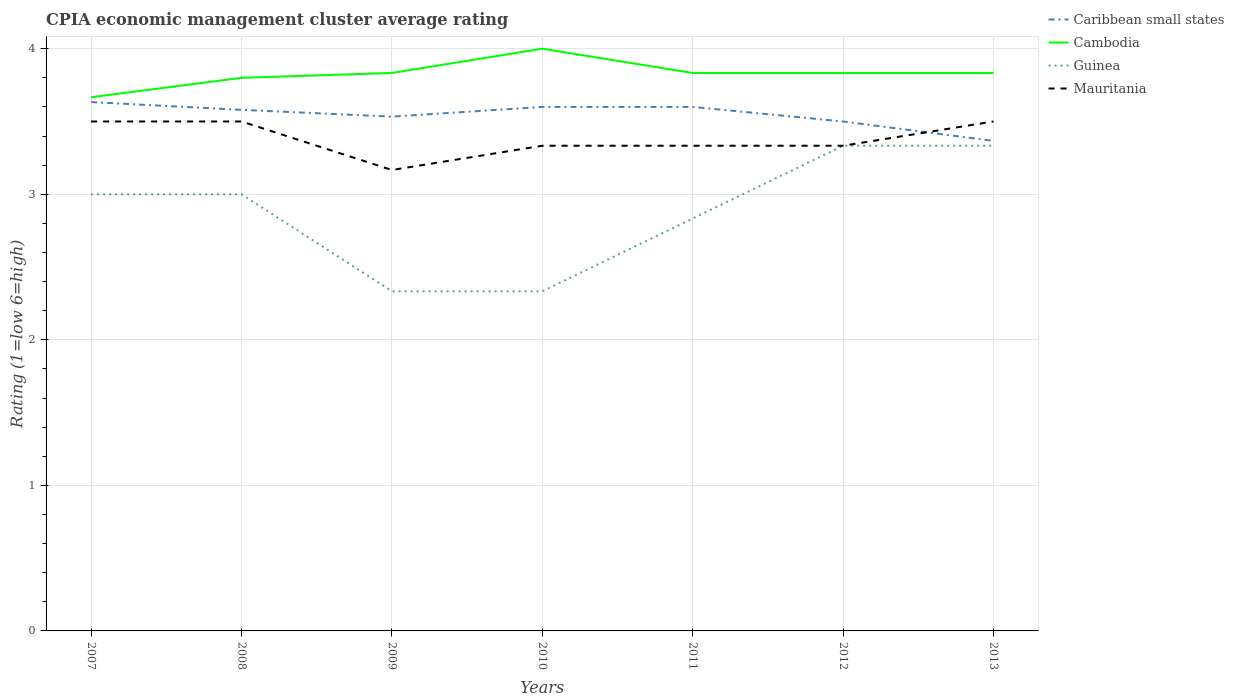How many different coloured lines are there?
Make the answer very short. 4. Does the line corresponding to Cambodia intersect with the line corresponding to Guinea?
Make the answer very short. No. Is the number of lines equal to the number of legend labels?
Give a very brief answer. Yes. Across all years, what is the maximum CPIA rating in Caribbean small states?
Your answer should be compact. 3.37. In which year was the CPIA rating in Cambodia maximum?
Keep it short and to the point. 2007. What is the total CPIA rating in Cambodia in the graph?
Provide a succinct answer. -0.17. What is the difference between the highest and the second highest CPIA rating in Caribbean small states?
Offer a terse response. 0.27. What is the difference between the highest and the lowest CPIA rating in Mauritania?
Give a very brief answer. 3. Is the CPIA rating in Mauritania strictly greater than the CPIA rating in Cambodia over the years?
Provide a succinct answer. Yes. How many lines are there?
Your answer should be compact. 4. How many years are there in the graph?
Your response must be concise. 7. Are the values on the major ticks of Y-axis written in scientific E-notation?
Give a very brief answer. No. Does the graph contain any zero values?
Give a very brief answer. No. Does the graph contain grids?
Your answer should be very brief. Yes. Where does the legend appear in the graph?
Keep it short and to the point. Top right. How are the legend labels stacked?
Keep it short and to the point. Vertical. What is the title of the graph?
Make the answer very short. CPIA economic management cluster average rating. Does "Euro area" appear as one of the legend labels in the graph?
Your answer should be very brief. No. What is the Rating (1=low 6=high) in Caribbean small states in 2007?
Your answer should be compact. 3.63. What is the Rating (1=low 6=high) of Cambodia in 2007?
Your answer should be compact. 3.67. What is the Rating (1=low 6=high) of Mauritania in 2007?
Keep it short and to the point. 3.5. What is the Rating (1=low 6=high) of Caribbean small states in 2008?
Give a very brief answer. 3.58. What is the Rating (1=low 6=high) of Cambodia in 2008?
Your answer should be very brief. 3.8. What is the Rating (1=low 6=high) in Mauritania in 2008?
Keep it short and to the point. 3.5. What is the Rating (1=low 6=high) in Caribbean small states in 2009?
Give a very brief answer. 3.53. What is the Rating (1=low 6=high) of Cambodia in 2009?
Keep it short and to the point. 3.83. What is the Rating (1=low 6=high) of Guinea in 2009?
Make the answer very short. 2.33. What is the Rating (1=low 6=high) in Mauritania in 2009?
Offer a very short reply. 3.17. What is the Rating (1=low 6=high) in Caribbean small states in 2010?
Provide a succinct answer. 3.6. What is the Rating (1=low 6=high) in Cambodia in 2010?
Keep it short and to the point. 4. What is the Rating (1=low 6=high) in Guinea in 2010?
Your answer should be compact. 2.33. What is the Rating (1=low 6=high) of Mauritania in 2010?
Provide a succinct answer. 3.33. What is the Rating (1=low 6=high) in Caribbean small states in 2011?
Make the answer very short. 3.6. What is the Rating (1=low 6=high) in Cambodia in 2011?
Give a very brief answer. 3.83. What is the Rating (1=low 6=high) of Guinea in 2011?
Keep it short and to the point. 2.83. What is the Rating (1=low 6=high) of Mauritania in 2011?
Keep it short and to the point. 3.33. What is the Rating (1=low 6=high) of Cambodia in 2012?
Provide a short and direct response. 3.83. What is the Rating (1=low 6=high) in Guinea in 2012?
Offer a terse response. 3.33. What is the Rating (1=low 6=high) of Mauritania in 2012?
Your answer should be very brief. 3.33. What is the Rating (1=low 6=high) in Caribbean small states in 2013?
Your answer should be very brief. 3.37. What is the Rating (1=low 6=high) of Cambodia in 2013?
Offer a very short reply. 3.83. What is the Rating (1=low 6=high) in Guinea in 2013?
Offer a terse response. 3.33. Across all years, what is the maximum Rating (1=low 6=high) of Caribbean small states?
Offer a terse response. 3.63. Across all years, what is the maximum Rating (1=low 6=high) of Cambodia?
Your response must be concise. 4. Across all years, what is the maximum Rating (1=low 6=high) of Guinea?
Ensure brevity in your answer.  3.33. Across all years, what is the maximum Rating (1=low 6=high) of Mauritania?
Your response must be concise. 3.5. Across all years, what is the minimum Rating (1=low 6=high) in Caribbean small states?
Provide a succinct answer. 3.37. Across all years, what is the minimum Rating (1=low 6=high) of Cambodia?
Keep it short and to the point. 3.67. Across all years, what is the minimum Rating (1=low 6=high) in Guinea?
Offer a terse response. 2.33. Across all years, what is the minimum Rating (1=low 6=high) of Mauritania?
Your answer should be compact. 3.17. What is the total Rating (1=low 6=high) of Caribbean small states in the graph?
Keep it short and to the point. 24.81. What is the total Rating (1=low 6=high) of Cambodia in the graph?
Ensure brevity in your answer.  26.8. What is the total Rating (1=low 6=high) of Guinea in the graph?
Your answer should be very brief. 20.17. What is the total Rating (1=low 6=high) in Mauritania in the graph?
Your answer should be compact. 23.67. What is the difference between the Rating (1=low 6=high) of Caribbean small states in 2007 and that in 2008?
Offer a terse response. 0.05. What is the difference between the Rating (1=low 6=high) of Cambodia in 2007 and that in 2008?
Your response must be concise. -0.13. What is the difference between the Rating (1=low 6=high) in Caribbean small states in 2007 and that in 2009?
Ensure brevity in your answer.  0.1. What is the difference between the Rating (1=low 6=high) in Caribbean small states in 2007 and that in 2010?
Keep it short and to the point. 0.03. What is the difference between the Rating (1=low 6=high) in Guinea in 2007 and that in 2010?
Give a very brief answer. 0.67. What is the difference between the Rating (1=low 6=high) of Mauritania in 2007 and that in 2010?
Offer a terse response. 0.17. What is the difference between the Rating (1=low 6=high) of Caribbean small states in 2007 and that in 2011?
Provide a succinct answer. 0.03. What is the difference between the Rating (1=low 6=high) in Caribbean small states in 2007 and that in 2012?
Your answer should be very brief. 0.13. What is the difference between the Rating (1=low 6=high) of Cambodia in 2007 and that in 2012?
Provide a short and direct response. -0.17. What is the difference between the Rating (1=low 6=high) of Caribbean small states in 2007 and that in 2013?
Provide a short and direct response. 0.27. What is the difference between the Rating (1=low 6=high) in Cambodia in 2007 and that in 2013?
Offer a terse response. -0.17. What is the difference between the Rating (1=low 6=high) of Mauritania in 2007 and that in 2013?
Offer a very short reply. 0. What is the difference between the Rating (1=low 6=high) in Caribbean small states in 2008 and that in 2009?
Your response must be concise. 0.05. What is the difference between the Rating (1=low 6=high) in Cambodia in 2008 and that in 2009?
Give a very brief answer. -0.03. What is the difference between the Rating (1=low 6=high) in Caribbean small states in 2008 and that in 2010?
Your response must be concise. -0.02. What is the difference between the Rating (1=low 6=high) of Caribbean small states in 2008 and that in 2011?
Ensure brevity in your answer.  -0.02. What is the difference between the Rating (1=low 6=high) of Cambodia in 2008 and that in 2011?
Your response must be concise. -0.03. What is the difference between the Rating (1=low 6=high) in Cambodia in 2008 and that in 2012?
Provide a succinct answer. -0.03. What is the difference between the Rating (1=low 6=high) in Caribbean small states in 2008 and that in 2013?
Ensure brevity in your answer.  0.21. What is the difference between the Rating (1=low 6=high) in Cambodia in 2008 and that in 2013?
Offer a very short reply. -0.03. What is the difference between the Rating (1=low 6=high) of Caribbean small states in 2009 and that in 2010?
Give a very brief answer. -0.07. What is the difference between the Rating (1=low 6=high) of Caribbean small states in 2009 and that in 2011?
Make the answer very short. -0.07. What is the difference between the Rating (1=low 6=high) of Mauritania in 2009 and that in 2011?
Ensure brevity in your answer.  -0.17. What is the difference between the Rating (1=low 6=high) in Guinea in 2009 and that in 2012?
Your response must be concise. -1. What is the difference between the Rating (1=low 6=high) of Mauritania in 2009 and that in 2012?
Your response must be concise. -0.17. What is the difference between the Rating (1=low 6=high) of Caribbean small states in 2010 and that in 2011?
Offer a terse response. 0. What is the difference between the Rating (1=low 6=high) in Cambodia in 2010 and that in 2011?
Give a very brief answer. 0.17. What is the difference between the Rating (1=low 6=high) in Mauritania in 2010 and that in 2011?
Provide a short and direct response. 0. What is the difference between the Rating (1=low 6=high) in Cambodia in 2010 and that in 2012?
Offer a very short reply. 0.17. What is the difference between the Rating (1=low 6=high) of Guinea in 2010 and that in 2012?
Offer a terse response. -1. What is the difference between the Rating (1=low 6=high) of Mauritania in 2010 and that in 2012?
Provide a short and direct response. 0. What is the difference between the Rating (1=low 6=high) in Caribbean small states in 2010 and that in 2013?
Provide a succinct answer. 0.23. What is the difference between the Rating (1=low 6=high) of Mauritania in 2010 and that in 2013?
Your answer should be compact. -0.17. What is the difference between the Rating (1=low 6=high) of Caribbean small states in 2011 and that in 2012?
Your response must be concise. 0.1. What is the difference between the Rating (1=low 6=high) of Guinea in 2011 and that in 2012?
Keep it short and to the point. -0.5. What is the difference between the Rating (1=low 6=high) of Mauritania in 2011 and that in 2012?
Your answer should be very brief. 0. What is the difference between the Rating (1=low 6=high) in Caribbean small states in 2011 and that in 2013?
Provide a short and direct response. 0.23. What is the difference between the Rating (1=low 6=high) in Cambodia in 2011 and that in 2013?
Your answer should be very brief. 0. What is the difference between the Rating (1=low 6=high) of Guinea in 2011 and that in 2013?
Your answer should be very brief. -0.5. What is the difference between the Rating (1=low 6=high) in Mauritania in 2011 and that in 2013?
Offer a terse response. -0.17. What is the difference between the Rating (1=low 6=high) in Caribbean small states in 2012 and that in 2013?
Keep it short and to the point. 0.13. What is the difference between the Rating (1=low 6=high) of Cambodia in 2012 and that in 2013?
Offer a terse response. 0. What is the difference between the Rating (1=low 6=high) in Caribbean small states in 2007 and the Rating (1=low 6=high) in Cambodia in 2008?
Offer a very short reply. -0.17. What is the difference between the Rating (1=low 6=high) of Caribbean small states in 2007 and the Rating (1=low 6=high) of Guinea in 2008?
Your answer should be compact. 0.63. What is the difference between the Rating (1=low 6=high) in Caribbean small states in 2007 and the Rating (1=low 6=high) in Mauritania in 2008?
Offer a terse response. 0.13. What is the difference between the Rating (1=low 6=high) in Guinea in 2007 and the Rating (1=low 6=high) in Mauritania in 2008?
Your answer should be very brief. -0.5. What is the difference between the Rating (1=low 6=high) of Caribbean small states in 2007 and the Rating (1=low 6=high) of Cambodia in 2009?
Keep it short and to the point. -0.2. What is the difference between the Rating (1=low 6=high) in Caribbean small states in 2007 and the Rating (1=low 6=high) in Mauritania in 2009?
Your response must be concise. 0.47. What is the difference between the Rating (1=low 6=high) in Cambodia in 2007 and the Rating (1=low 6=high) in Mauritania in 2009?
Give a very brief answer. 0.5. What is the difference between the Rating (1=low 6=high) of Caribbean small states in 2007 and the Rating (1=low 6=high) of Cambodia in 2010?
Your response must be concise. -0.37. What is the difference between the Rating (1=low 6=high) of Caribbean small states in 2007 and the Rating (1=low 6=high) of Mauritania in 2010?
Your answer should be compact. 0.3. What is the difference between the Rating (1=low 6=high) of Caribbean small states in 2007 and the Rating (1=low 6=high) of Cambodia in 2011?
Your response must be concise. -0.2. What is the difference between the Rating (1=low 6=high) of Caribbean small states in 2007 and the Rating (1=low 6=high) of Guinea in 2011?
Provide a short and direct response. 0.8. What is the difference between the Rating (1=low 6=high) of Cambodia in 2007 and the Rating (1=low 6=high) of Guinea in 2011?
Provide a short and direct response. 0.83. What is the difference between the Rating (1=low 6=high) of Cambodia in 2007 and the Rating (1=low 6=high) of Mauritania in 2011?
Your response must be concise. 0.33. What is the difference between the Rating (1=low 6=high) in Caribbean small states in 2007 and the Rating (1=low 6=high) in Cambodia in 2012?
Your answer should be very brief. -0.2. What is the difference between the Rating (1=low 6=high) in Caribbean small states in 2007 and the Rating (1=low 6=high) in Guinea in 2012?
Your answer should be very brief. 0.3. What is the difference between the Rating (1=low 6=high) in Cambodia in 2007 and the Rating (1=low 6=high) in Guinea in 2012?
Offer a terse response. 0.33. What is the difference between the Rating (1=low 6=high) in Guinea in 2007 and the Rating (1=low 6=high) in Mauritania in 2012?
Your answer should be very brief. -0.33. What is the difference between the Rating (1=low 6=high) in Caribbean small states in 2007 and the Rating (1=low 6=high) in Cambodia in 2013?
Give a very brief answer. -0.2. What is the difference between the Rating (1=low 6=high) of Caribbean small states in 2007 and the Rating (1=low 6=high) of Guinea in 2013?
Your answer should be very brief. 0.3. What is the difference between the Rating (1=low 6=high) in Caribbean small states in 2007 and the Rating (1=low 6=high) in Mauritania in 2013?
Your answer should be very brief. 0.13. What is the difference between the Rating (1=low 6=high) of Caribbean small states in 2008 and the Rating (1=low 6=high) of Cambodia in 2009?
Offer a very short reply. -0.25. What is the difference between the Rating (1=low 6=high) in Caribbean small states in 2008 and the Rating (1=low 6=high) in Guinea in 2009?
Give a very brief answer. 1.25. What is the difference between the Rating (1=low 6=high) in Caribbean small states in 2008 and the Rating (1=low 6=high) in Mauritania in 2009?
Your answer should be compact. 0.41. What is the difference between the Rating (1=low 6=high) in Cambodia in 2008 and the Rating (1=low 6=high) in Guinea in 2009?
Your answer should be compact. 1.47. What is the difference between the Rating (1=low 6=high) of Cambodia in 2008 and the Rating (1=low 6=high) of Mauritania in 2009?
Provide a succinct answer. 0.63. What is the difference between the Rating (1=low 6=high) of Caribbean small states in 2008 and the Rating (1=low 6=high) of Cambodia in 2010?
Offer a terse response. -0.42. What is the difference between the Rating (1=low 6=high) of Caribbean small states in 2008 and the Rating (1=low 6=high) of Guinea in 2010?
Offer a very short reply. 1.25. What is the difference between the Rating (1=low 6=high) of Caribbean small states in 2008 and the Rating (1=low 6=high) of Mauritania in 2010?
Your answer should be very brief. 0.25. What is the difference between the Rating (1=low 6=high) in Cambodia in 2008 and the Rating (1=low 6=high) in Guinea in 2010?
Provide a succinct answer. 1.47. What is the difference between the Rating (1=low 6=high) of Cambodia in 2008 and the Rating (1=low 6=high) of Mauritania in 2010?
Make the answer very short. 0.47. What is the difference between the Rating (1=low 6=high) of Caribbean small states in 2008 and the Rating (1=low 6=high) of Cambodia in 2011?
Provide a succinct answer. -0.25. What is the difference between the Rating (1=low 6=high) of Caribbean small states in 2008 and the Rating (1=low 6=high) of Guinea in 2011?
Offer a very short reply. 0.75. What is the difference between the Rating (1=low 6=high) in Caribbean small states in 2008 and the Rating (1=low 6=high) in Mauritania in 2011?
Ensure brevity in your answer.  0.25. What is the difference between the Rating (1=low 6=high) of Cambodia in 2008 and the Rating (1=low 6=high) of Guinea in 2011?
Make the answer very short. 0.97. What is the difference between the Rating (1=low 6=high) of Cambodia in 2008 and the Rating (1=low 6=high) of Mauritania in 2011?
Offer a terse response. 0.47. What is the difference between the Rating (1=low 6=high) of Caribbean small states in 2008 and the Rating (1=low 6=high) of Cambodia in 2012?
Provide a short and direct response. -0.25. What is the difference between the Rating (1=low 6=high) in Caribbean small states in 2008 and the Rating (1=low 6=high) in Guinea in 2012?
Give a very brief answer. 0.25. What is the difference between the Rating (1=low 6=high) of Caribbean small states in 2008 and the Rating (1=low 6=high) of Mauritania in 2012?
Provide a succinct answer. 0.25. What is the difference between the Rating (1=low 6=high) of Cambodia in 2008 and the Rating (1=low 6=high) of Guinea in 2012?
Your answer should be very brief. 0.47. What is the difference between the Rating (1=low 6=high) in Cambodia in 2008 and the Rating (1=low 6=high) in Mauritania in 2012?
Keep it short and to the point. 0.47. What is the difference between the Rating (1=low 6=high) in Guinea in 2008 and the Rating (1=low 6=high) in Mauritania in 2012?
Your response must be concise. -0.33. What is the difference between the Rating (1=low 6=high) in Caribbean small states in 2008 and the Rating (1=low 6=high) in Cambodia in 2013?
Provide a succinct answer. -0.25. What is the difference between the Rating (1=low 6=high) of Caribbean small states in 2008 and the Rating (1=low 6=high) of Guinea in 2013?
Offer a very short reply. 0.25. What is the difference between the Rating (1=low 6=high) of Cambodia in 2008 and the Rating (1=low 6=high) of Guinea in 2013?
Provide a short and direct response. 0.47. What is the difference between the Rating (1=low 6=high) in Guinea in 2008 and the Rating (1=low 6=high) in Mauritania in 2013?
Your answer should be compact. -0.5. What is the difference between the Rating (1=low 6=high) of Caribbean small states in 2009 and the Rating (1=low 6=high) of Cambodia in 2010?
Ensure brevity in your answer.  -0.47. What is the difference between the Rating (1=low 6=high) in Caribbean small states in 2009 and the Rating (1=low 6=high) in Guinea in 2010?
Ensure brevity in your answer.  1.2. What is the difference between the Rating (1=low 6=high) in Caribbean small states in 2009 and the Rating (1=low 6=high) in Mauritania in 2010?
Provide a short and direct response. 0.2. What is the difference between the Rating (1=low 6=high) of Cambodia in 2009 and the Rating (1=low 6=high) of Mauritania in 2010?
Your answer should be compact. 0.5. What is the difference between the Rating (1=low 6=high) in Guinea in 2009 and the Rating (1=low 6=high) in Mauritania in 2010?
Make the answer very short. -1. What is the difference between the Rating (1=low 6=high) of Caribbean small states in 2009 and the Rating (1=low 6=high) of Cambodia in 2011?
Give a very brief answer. -0.3. What is the difference between the Rating (1=low 6=high) of Caribbean small states in 2009 and the Rating (1=low 6=high) of Guinea in 2011?
Your response must be concise. 0.7. What is the difference between the Rating (1=low 6=high) of Caribbean small states in 2009 and the Rating (1=low 6=high) of Mauritania in 2011?
Keep it short and to the point. 0.2. What is the difference between the Rating (1=low 6=high) in Cambodia in 2009 and the Rating (1=low 6=high) in Mauritania in 2011?
Give a very brief answer. 0.5. What is the difference between the Rating (1=low 6=high) of Guinea in 2009 and the Rating (1=low 6=high) of Mauritania in 2011?
Provide a short and direct response. -1. What is the difference between the Rating (1=low 6=high) of Caribbean small states in 2009 and the Rating (1=low 6=high) of Mauritania in 2012?
Your answer should be very brief. 0.2. What is the difference between the Rating (1=low 6=high) in Cambodia in 2009 and the Rating (1=low 6=high) in Guinea in 2012?
Your response must be concise. 0.5. What is the difference between the Rating (1=low 6=high) of Cambodia in 2009 and the Rating (1=low 6=high) of Mauritania in 2012?
Provide a short and direct response. 0.5. What is the difference between the Rating (1=low 6=high) of Guinea in 2009 and the Rating (1=low 6=high) of Mauritania in 2012?
Provide a succinct answer. -1. What is the difference between the Rating (1=low 6=high) in Caribbean small states in 2009 and the Rating (1=low 6=high) in Cambodia in 2013?
Your answer should be compact. -0.3. What is the difference between the Rating (1=low 6=high) of Caribbean small states in 2009 and the Rating (1=low 6=high) of Mauritania in 2013?
Offer a terse response. 0.03. What is the difference between the Rating (1=low 6=high) in Cambodia in 2009 and the Rating (1=low 6=high) in Guinea in 2013?
Your answer should be very brief. 0.5. What is the difference between the Rating (1=low 6=high) in Cambodia in 2009 and the Rating (1=low 6=high) in Mauritania in 2013?
Provide a succinct answer. 0.33. What is the difference between the Rating (1=low 6=high) in Guinea in 2009 and the Rating (1=low 6=high) in Mauritania in 2013?
Give a very brief answer. -1.17. What is the difference between the Rating (1=low 6=high) in Caribbean small states in 2010 and the Rating (1=low 6=high) in Cambodia in 2011?
Keep it short and to the point. -0.23. What is the difference between the Rating (1=low 6=high) in Caribbean small states in 2010 and the Rating (1=low 6=high) in Guinea in 2011?
Your answer should be compact. 0.77. What is the difference between the Rating (1=low 6=high) of Caribbean small states in 2010 and the Rating (1=low 6=high) of Mauritania in 2011?
Ensure brevity in your answer.  0.27. What is the difference between the Rating (1=low 6=high) of Cambodia in 2010 and the Rating (1=low 6=high) of Guinea in 2011?
Ensure brevity in your answer.  1.17. What is the difference between the Rating (1=low 6=high) of Guinea in 2010 and the Rating (1=low 6=high) of Mauritania in 2011?
Your response must be concise. -1. What is the difference between the Rating (1=low 6=high) of Caribbean small states in 2010 and the Rating (1=low 6=high) of Cambodia in 2012?
Your answer should be compact. -0.23. What is the difference between the Rating (1=low 6=high) in Caribbean small states in 2010 and the Rating (1=low 6=high) in Guinea in 2012?
Make the answer very short. 0.27. What is the difference between the Rating (1=low 6=high) of Caribbean small states in 2010 and the Rating (1=low 6=high) of Mauritania in 2012?
Give a very brief answer. 0.27. What is the difference between the Rating (1=low 6=high) in Cambodia in 2010 and the Rating (1=low 6=high) in Guinea in 2012?
Make the answer very short. 0.67. What is the difference between the Rating (1=low 6=high) in Cambodia in 2010 and the Rating (1=low 6=high) in Mauritania in 2012?
Provide a short and direct response. 0.67. What is the difference between the Rating (1=low 6=high) of Guinea in 2010 and the Rating (1=low 6=high) of Mauritania in 2012?
Offer a terse response. -1. What is the difference between the Rating (1=low 6=high) in Caribbean small states in 2010 and the Rating (1=low 6=high) in Cambodia in 2013?
Provide a short and direct response. -0.23. What is the difference between the Rating (1=low 6=high) in Caribbean small states in 2010 and the Rating (1=low 6=high) in Guinea in 2013?
Your response must be concise. 0.27. What is the difference between the Rating (1=low 6=high) of Caribbean small states in 2010 and the Rating (1=low 6=high) of Mauritania in 2013?
Make the answer very short. 0.1. What is the difference between the Rating (1=low 6=high) of Cambodia in 2010 and the Rating (1=low 6=high) of Guinea in 2013?
Make the answer very short. 0.67. What is the difference between the Rating (1=low 6=high) of Cambodia in 2010 and the Rating (1=low 6=high) of Mauritania in 2013?
Your answer should be compact. 0.5. What is the difference between the Rating (1=low 6=high) of Guinea in 2010 and the Rating (1=low 6=high) of Mauritania in 2013?
Your answer should be compact. -1.17. What is the difference between the Rating (1=low 6=high) of Caribbean small states in 2011 and the Rating (1=low 6=high) of Cambodia in 2012?
Make the answer very short. -0.23. What is the difference between the Rating (1=low 6=high) of Caribbean small states in 2011 and the Rating (1=low 6=high) of Guinea in 2012?
Your answer should be very brief. 0.27. What is the difference between the Rating (1=low 6=high) of Caribbean small states in 2011 and the Rating (1=low 6=high) of Mauritania in 2012?
Give a very brief answer. 0.27. What is the difference between the Rating (1=low 6=high) in Cambodia in 2011 and the Rating (1=low 6=high) in Guinea in 2012?
Your answer should be very brief. 0.5. What is the difference between the Rating (1=low 6=high) in Guinea in 2011 and the Rating (1=low 6=high) in Mauritania in 2012?
Keep it short and to the point. -0.5. What is the difference between the Rating (1=low 6=high) in Caribbean small states in 2011 and the Rating (1=low 6=high) in Cambodia in 2013?
Your answer should be very brief. -0.23. What is the difference between the Rating (1=low 6=high) of Caribbean small states in 2011 and the Rating (1=low 6=high) of Guinea in 2013?
Keep it short and to the point. 0.27. What is the difference between the Rating (1=low 6=high) of Caribbean small states in 2011 and the Rating (1=low 6=high) of Mauritania in 2013?
Ensure brevity in your answer.  0.1. What is the difference between the Rating (1=low 6=high) in Cambodia in 2011 and the Rating (1=low 6=high) in Guinea in 2013?
Offer a terse response. 0.5. What is the difference between the Rating (1=low 6=high) in Cambodia in 2011 and the Rating (1=low 6=high) in Mauritania in 2013?
Your answer should be very brief. 0.33. What is the difference between the Rating (1=low 6=high) of Guinea in 2011 and the Rating (1=low 6=high) of Mauritania in 2013?
Give a very brief answer. -0.67. What is the difference between the Rating (1=low 6=high) in Caribbean small states in 2012 and the Rating (1=low 6=high) in Cambodia in 2013?
Provide a short and direct response. -0.33. What is the difference between the Rating (1=low 6=high) in Caribbean small states in 2012 and the Rating (1=low 6=high) in Guinea in 2013?
Your answer should be compact. 0.17. What is the difference between the Rating (1=low 6=high) in Cambodia in 2012 and the Rating (1=low 6=high) in Mauritania in 2013?
Your answer should be compact. 0.33. What is the average Rating (1=low 6=high) of Caribbean small states per year?
Your response must be concise. 3.54. What is the average Rating (1=low 6=high) of Cambodia per year?
Keep it short and to the point. 3.83. What is the average Rating (1=low 6=high) of Guinea per year?
Your answer should be very brief. 2.88. What is the average Rating (1=low 6=high) in Mauritania per year?
Offer a very short reply. 3.38. In the year 2007, what is the difference between the Rating (1=low 6=high) of Caribbean small states and Rating (1=low 6=high) of Cambodia?
Your answer should be very brief. -0.03. In the year 2007, what is the difference between the Rating (1=low 6=high) in Caribbean small states and Rating (1=low 6=high) in Guinea?
Make the answer very short. 0.63. In the year 2007, what is the difference between the Rating (1=low 6=high) in Caribbean small states and Rating (1=low 6=high) in Mauritania?
Keep it short and to the point. 0.13. In the year 2008, what is the difference between the Rating (1=low 6=high) of Caribbean small states and Rating (1=low 6=high) of Cambodia?
Your answer should be very brief. -0.22. In the year 2008, what is the difference between the Rating (1=low 6=high) of Caribbean small states and Rating (1=low 6=high) of Guinea?
Your answer should be very brief. 0.58. In the year 2008, what is the difference between the Rating (1=low 6=high) of Cambodia and Rating (1=low 6=high) of Mauritania?
Your answer should be compact. 0.3. In the year 2009, what is the difference between the Rating (1=low 6=high) in Caribbean small states and Rating (1=low 6=high) in Guinea?
Offer a terse response. 1.2. In the year 2009, what is the difference between the Rating (1=low 6=high) in Caribbean small states and Rating (1=low 6=high) in Mauritania?
Offer a terse response. 0.37. In the year 2009, what is the difference between the Rating (1=low 6=high) in Cambodia and Rating (1=low 6=high) in Mauritania?
Ensure brevity in your answer.  0.67. In the year 2010, what is the difference between the Rating (1=low 6=high) in Caribbean small states and Rating (1=low 6=high) in Cambodia?
Your answer should be compact. -0.4. In the year 2010, what is the difference between the Rating (1=low 6=high) of Caribbean small states and Rating (1=low 6=high) of Guinea?
Your answer should be very brief. 1.27. In the year 2010, what is the difference between the Rating (1=low 6=high) of Caribbean small states and Rating (1=low 6=high) of Mauritania?
Keep it short and to the point. 0.27. In the year 2011, what is the difference between the Rating (1=low 6=high) of Caribbean small states and Rating (1=low 6=high) of Cambodia?
Give a very brief answer. -0.23. In the year 2011, what is the difference between the Rating (1=low 6=high) of Caribbean small states and Rating (1=low 6=high) of Guinea?
Provide a short and direct response. 0.77. In the year 2011, what is the difference between the Rating (1=low 6=high) in Caribbean small states and Rating (1=low 6=high) in Mauritania?
Your answer should be compact. 0.27. In the year 2011, what is the difference between the Rating (1=low 6=high) of Cambodia and Rating (1=low 6=high) of Guinea?
Keep it short and to the point. 1. In the year 2011, what is the difference between the Rating (1=low 6=high) in Cambodia and Rating (1=low 6=high) in Mauritania?
Offer a terse response. 0.5. In the year 2011, what is the difference between the Rating (1=low 6=high) in Guinea and Rating (1=low 6=high) in Mauritania?
Your response must be concise. -0.5. In the year 2012, what is the difference between the Rating (1=low 6=high) in Caribbean small states and Rating (1=low 6=high) in Cambodia?
Ensure brevity in your answer.  -0.33. In the year 2012, what is the difference between the Rating (1=low 6=high) in Caribbean small states and Rating (1=low 6=high) in Mauritania?
Provide a short and direct response. 0.17. In the year 2012, what is the difference between the Rating (1=low 6=high) of Cambodia and Rating (1=low 6=high) of Mauritania?
Offer a very short reply. 0.5. In the year 2012, what is the difference between the Rating (1=low 6=high) in Guinea and Rating (1=low 6=high) in Mauritania?
Your answer should be compact. 0. In the year 2013, what is the difference between the Rating (1=low 6=high) in Caribbean small states and Rating (1=low 6=high) in Cambodia?
Your answer should be compact. -0.47. In the year 2013, what is the difference between the Rating (1=low 6=high) of Caribbean small states and Rating (1=low 6=high) of Guinea?
Give a very brief answer. 0.03. In the year 2013, what is the difference between the Rating (1=low 6=high) in Caribbean small states and Rating (1=low 6=high) in Mauritania?
Give a very brief answer. -0.13. In the year 2013, what is the difference between the Rating (1=low 6=high) in Cambodia and Rating (1=low 6=high) in Mauritania?
Ensure brevity in your answer.  0.33. In the year 2013, what is the difference between the Rating (1=low 6=high) of Guinea and Rating (1=low 6=high) of Mauritania?
Keep it short and to the point. -0.17. What is the ratio of the Rating (1=low 6=high) of Caribbean small states in 2007 to that in 2008?
Keep it short and to the point. 1.01. What is the ratio of the Rating (1=low 6=high) in Cambodia in 2007 to that in 2008?
Give a very brief answer. 0.96. What is the ratio of the Rating (1=low 6=high) of Mauritania in 2007 to that in 2008?
Keep it short and to the point. 1. What is the ratio of the Rating (1=low 6=high) of Caribbean small states in 2007 to that in 2009?
Your answer should be compact. 1.03. What is the ratio of the Rating (1=low 6=high) in Cambodia in 2007 to that in 2009?
Make the answer very short. 0.96. What is the ratio of the Rating (1=low 6=high) in Guinea in 2007 to that in 2009?
Your answer should be very brief. 1.29. What is the ratio of the Rating (1=low 6=high) of Mauritania in 2007 to that in 2009?
Offer a terse response. 1.11. What is the ratio of the Rating (1=low 6=high) of Caribbean small states in 2007 to that in 2010?
Keep it short and to the point. 1.01. What is the ratio of the Rating (1=low 6=high) in Mauritania in 2007 to that in 2010?
Your answer should be compact. 1.05. What is the ratio of the Rating (1=low 6=high) of Caribbean small states in 2007 to that in 2011?
Give a very brief answer. 1.01. What is the ratio of the Rating (1=low 6=high) of Cambodia in 2007 to that in 2011?
Your response must be concise. 0.96. What is the ratio of the Rating (1=low 6=high) of Guinea in 2007 to that in 2011?
Your response must be concise. 1.06. What is the ratio of the Rating (1=low 6=high) of Mauritania in 2007 to that in 2011?
Your response must be concise. 1.05. What is the ratio of the Rating (1=low 6=high) in Caribbean small states in 2007 to that in 2012?
Give a very brief answer. 1.04. What is the ratio of the Rating (1=low 6=high) of Cambodia in 2007 to that in 2012?
Ensure brevity in your answer.  0.96. What is the ratio of the Rating (1=low 6=high) of Guinea in 2007 to that in 2012?
Provide a succinct answer. 0.9. What is the ratio of the Rating (1=low 6=high) of Caribbean small states in 2007 to that in 2013?
Your answer should be very brief. 1.08. What is the ratio of the Rating (1=low 6=high) of Cambodia in 2007 to that in 2013?
Make the answer very short. 0.96. What is the ratio of the Rating (1=low 6=high) of Guinea in 2007 to that in 2013?
Offer a terse response. 0.9. What is the ratio of the Rating (1=low 6=high) in Caribbean small states in 2008 to that in 2009?
Your answer should be compact. 1.01. What is the ratio of the Rating (1=low 6=high) of Cambodia in 2008 to that in 2009?
Provide a short and direct response. 0.99. What is the ratio of the Rating (1=low 6=high) in Mauritania in 2008 to that in 2009?
Your answer should be very brief. 1.11. What is the ratio of the Rating (1=low 6=high) in Caribbean small states in 2008 to that in 2010?
Ensure brevity in your answer.  0.99. What is the ratio of the Rating (1=low 6=high) in Cambodia in 2008 to that in 2010?
Provide a short and direct response. 0.95. What is the ratio of the Rating (1=low 6=high) in Guinea in 2008 to that in 2010?
Give a very brief answer. 1.29. What is the ratio of the Rating (1=low 6=high) in Mauritania in 2008 to that in 2010?
Keep it short and to the point. 1.05. What is the ratio of the Rating (1=low 6=high) of Caribbean small states in 2008 to that in 2011?
Offer a terse response. 0.99. What is the ratio of the Rating (1=low 6=high) in Guinea in 2008 to that in 2011?
Offer a very short reply. 1.06. What is the ratio of the Rating (1=low 6=high) of Caribbean small states in 2008 to that in 2012?
Offer a very short reply. 1.02. What is the ratio of the Rating (1=low 6=high) of Mauritania in 2008 to that in 2012?
Your answer should be compact. 1.05. What is the ratio of the Rating (1=low 6=high) in Caribbean small states in 2008 to that in 2013?
Keep it short and to the point. 1.06. What is the ratio of the Rating (1=low 6=high) in Cambodia in 2008 to that in 2013?
Your response must be concise. 0.99. What is the ratio of the Rating (1=low 6=high) in Guinea in 2008 to that in 2013?
Make the answer very short. 0.9. What is the ratio of the Rating (1=low 6=high) of Caribbean small states in 2009 to that in 2010?
Keep it short and to the point. 0.98. What is the ratio of the Rating (1=low 6=high) in Guinea in 2009 to that in 2010?
Your response must be concise. 1. What is the ratio of the Rating (1=low 6=high) of Caribbean small states in 2009 to that in 2011?
Your response must be concise. 0.98. What is the ratio of the Rating (1=low 6=high) of Guinea in 2009 to that in 2011?
Keep it short and to the point. 0.82. What is the ratio of the Rating (1=low 6=high) in Caribbean small states in 2009 to that in 2012?
Offer a terse response. 1.01. What is the ratio of the Rating (1=low 6=high) in Cambodia in 2009 to that in 2012?
Ensure brevity in your answer.  1. What is the ratio of the Rating (1=low 6=high) in Guinea in 2009 to that in 2012?
Offer a very short reply. 0.7. What is the ratio of the Rating (1=low 6=high) in Mauritania in 2009 to that in 2012?
Your answer should be very brief. 0.95. What is the ratio of the Rating (1=low 6=high) of Caribbean small states in 2009 to that in 2013?
Offer a terse response. 1.05. What is the ratio of the Rating (1=low 6=high) in Mauritania in 2009 to that in 2013?
Offer a terse response. 0.9. What is the ratio of the Rating (1=low 6=high) of Caribbean small states in 2010 to that in 2011?
Keep it short and to the point. 1. What is the ratio of the Rating (1=low 6=high) in Cambodia in 2010 to that in 2011?
Your response must be concise. 1.04. What is the ratio of the Rating (1=low 6=high) in Guinea in 2010 to that in 2011?
Your response must be concise. 0.82. What is the ratio of the Rating (1=low 6=high) in Caribbean small states in 2010 to that in 2012?
Your answer should be very brief. 1.03. What is the ratio of the Rating (1=low 6=high) in Cambodia in 2010 to that in 2012?
Give a very brief answer. 1.04. What is the ratio of the Rating (1=low 6=high) in Guinea in 2010 to that in 2012?
Keep it short and to the point. 0.7. What is the ratio of the Rating (1=low 6=high) of Caribbean small states in 2010 to that in 2013?
Ensure brevity in your answer.  1.07. What is the ratio of the Rating (1=low 6=high) of Cambodia in 2010 to that in 2013?
Keep it short and to the point. 1.04. What is the ratio of the Rating (1=low 6=high) of Guinea in 2010 to that in 2013?
Ensure brevity in your answer.  0.7. What is the ratio of the Rating (1=low 6=high) of Mauritania in 2010 to that in 2013?
Make the answer very short. 0.95. What is the ratio of the Rating (1=low 6=high) in Caribbean small states in 2011 to that in 2012?
Your response must be concise. 1.03. What is the ratio of the Rating (1=low 6=high) of Cambodia in 2011 to that in 2012?
Provide a succinct answer. 1. What is the ratio of the Rating (1=low 6=high) in Guinea in 2011 to that in 2012?
Your answer should be very brief. 0.85. What is the ratio of the Rating (1=low 6=high) of Caribbean small states in 2011 to that in 2013?
Provide a short and direct response. 1.07. What is the ratio of the Rating (1=low 6=high) of Guinea in 2011 to that in 2013?
Provide a short and direct response. 0.85. What is the ratio of the Rating (1=low 6=high) in Caribbean small states in 2012 to that in 2013?
Provide a short and direct response. 1.04. What is the ratio of the Rating (1=low 6=high) of Mauritania in 2012 to that in 2013?
Keep it short and to the point. 0.95. What is the difference between the highest and the second highest Rating (1=low 6=high) in Caribbean small states?
Your answer should be very brief. 0.03. What is the difference between the highest and the second highest Rating (1=low 6=high) of Mauritania?
Provide a short and direct response. 0. What is the difference between the highest and the lowest Rating (1=low 6=high) of Caribbean small states?
Your answer should be compact. 0.27. What is the difference between the highest and the lowest Rating (1=low 6=high) in Cambodia?
Ensure brevity in your answer.  0.33. What is the difference between the highest and the lowest Rating (1=low 6=high) of Guinea?
Your answer should be compact. 1. What is the difference between the highest and the lowest Rating (1=low 6=high) in Mauritania?
Offer a terse response. 0.33. 